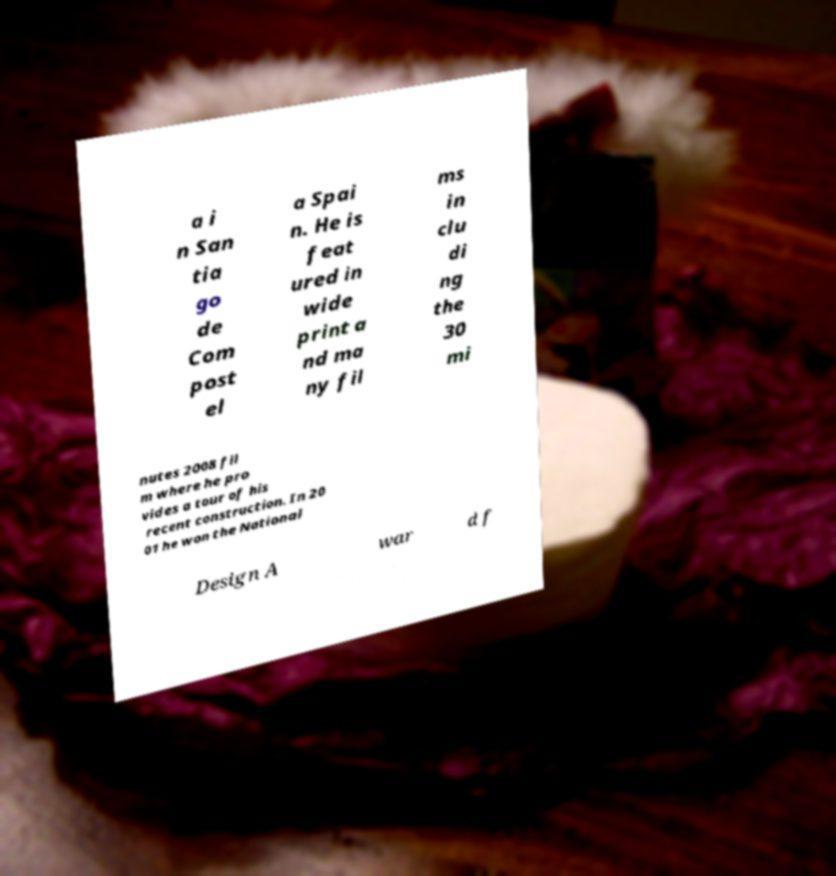What messages or text are displayed in this image? I need them in a readable, typed format. a i n San tia go de Com post el a Spai n. He is feat ured in wide print a nd ma ny fil ms in clu di ng the 30 mi nutes 2008 fil m where he pro vides a tour of his recent construction. In 20 01 he won the National Design A war d f 